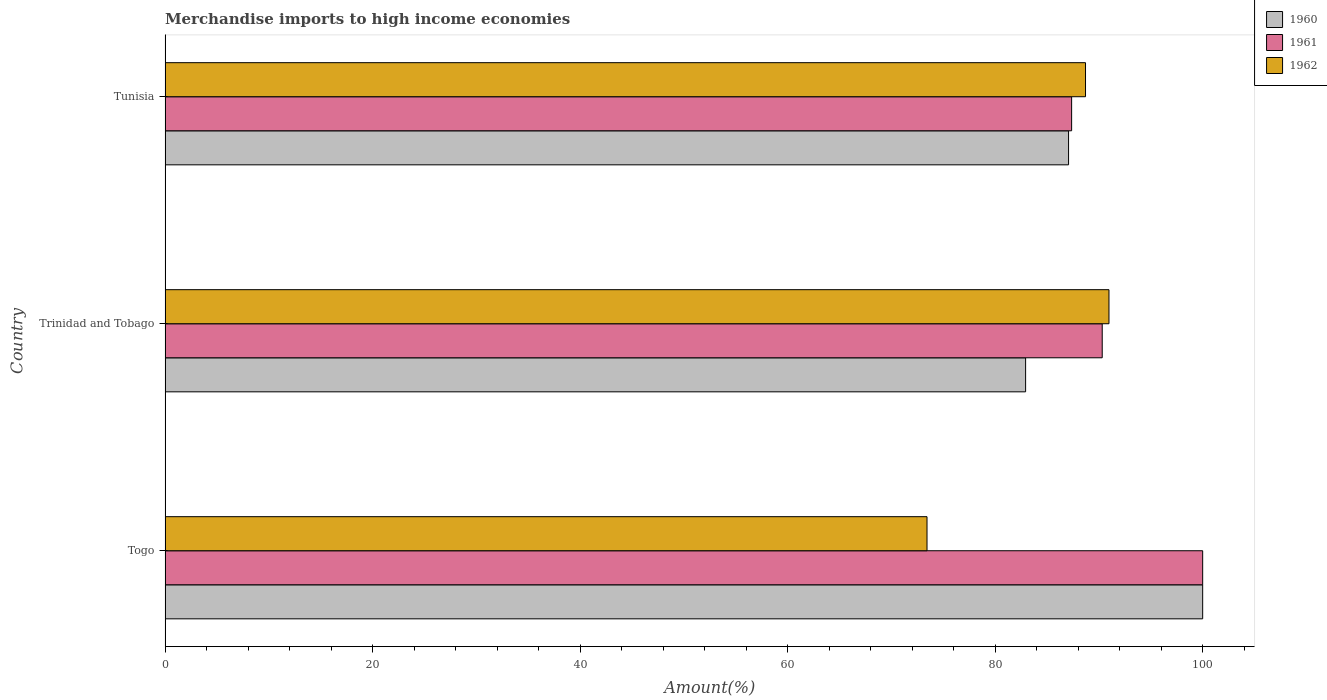Are the number of bars per tick equal to the number of legend labels?
Your answer should be very brief. Yes. How many bars are there on the 1st tick from the top?
Offer a very short reply. 3. What is the label of the 2nd group of bars from the top?
Ensure brevity in your answer.  Trinidad and Tobago. What is the percentage of amount earned from merchandise imports in 1960 in Tunisia?
Make the answer very short. 87.07. Across all countries, what is the maximum percentage of amount earned from merchandise imports in 1962?
Keep it short and to the point. 90.97. Across all countries, what is the minimum percentage of amount earned from merchandise imports in 1960?
Give a very brief answer. 82.93. In which country was the percentage of amount earned from merchandise imports in 1962 maximum?
Provide a succinct answer. Trinidad and Tobago. In which country was the percentage of amount earned from merchandise imports in 1960 minimum?
Provide a short and direct response. Trinidad and Tobago. What is the total percentage of amount earned from merchandise imports in 1961 in the graph?
Give a very brief answer. 277.69. What is the difference between the percentage of amount earned from merchandise imports in 1961 in Togo and that in Trinidad and Tobago?
Your response must be concise. 9.68. What is the difference between the percentage of amount earned from merchandise imports in 1962 in Tunisia and the percentage of amount earned from merchandise imports in 1961 in Trinidad and Tobago?
Provide a succinct answer. -1.61. What is the average percentage of amount earned from merchandise imports in 1960 per country?
Offer a very short reply. 90. What is the difference between the percentage of amount earned from merchandise imports in 1961 and percentage of amount earned from merchandise imports in 1960 in Trinidad and Tobago?
Provide a succinct answer. 7.38. What is the ratio of the percentage of amount earned from merchandise imports in 1960 in Togo to that in Trinidad and Tobago?
Give a very brief answer. 1.21. Is the percentage of amount earned from merchandise imports in 1961 in Togo less than that in Tunisia?
Your response must be concise. No. What is the difference between the highest and the second highest percentage of amount earned from merchandise imports in 1960?
Give a very brief answer. 12.93. What is the difference between the highest and the lowest percentage of amount earned from merchandise imports in 1962?
Provide a succinct answer. 17.54. What does the 2nd bar from the top in Trinidad and Tobago represents?
Your response must be concise. 1961. What is the difference between two consecutive major ticks on the X-axis?
Offer a very short reply. 20. Where does the legend appear in the graph?
Provide a succinct answer. Top right. How many legend labels are there?
Offer a very short reply. 3. What is the title of the graph?
Your answer should be very brief. Merchandise imports to high income economies. Does "1961" appear as one of the legend labels in the graph?
Offer a very short reply. Yes. What is the label or title of the X-axis?
Make the answer very short. Amount(%). What is the label or title of the Y-axis?
Provide a succinct answer. Country. What is the Amount(%) of 1962 in Togo?
Provide a short and direct response. 73.43. What is the Amount(%) of 1960 in Trinidad and Tobago?
Keep it short and to the point. 82.93. What is the Amount(%) in 1961 in Trinidad and Tobago?
Give a very brief answer. 90.32. What is the Amount(%) of 1962 in Trinidad and Tobago?
Offer a very short reply. 90.97. What is the Amount(%) of 1960 in Tunisia?
Provide a short and direct response. 87.07. What is the Amount(%) in 1961 in Tunisia?
Provide a short and direct response. 87.37. What is the Amount(%) in 1962 in Tunisia?
Keep it short and to the point. 88.71. Across all countries, what is the maximum Amount(%) of 1960?
Offer a terse response. 100. Across all countries, what is the maximum Amount(%) of 1961?
Give a very brief answer. 100. Across all countries, what is the maximum Amount(%) of 1962?
Give a very brief answer. 90.97. Across all countries, what is the minimum Amount(%) of 1960?
Make the answer very short. 82.93. Across all countries, what is the minimum Amount(%) in 1961?
Provide a succinct answer. 87.37. Across all countries, what is the minimum Amount(%) of 1962?
Provide a succinct answer. 73.43. What is the total Amount(%) in 1960 in the graph?
Offer a very short reply. 270.01. What is the total Amount(%) in 1961 in the graph?
Make the answer very short. 277.69. What is the total Amount(%) in 1962 in the graph?
Provide a succinct answer. 253.11. What is the difference between the Amount(%) in 1960 in Togo and that in Trinidad and Tobago?
Keep it short and to the point. 17.07. What is the difference between the Amount(%) of 1961 in Togo and that in Trinidad and Tobago?
Your answer should be compact. 9.68. What is the difference between the Amount(%) of 1962 in Togo and that in Trinidad and Tobago?
Keep it short and to the point. -17.54. What is the difference between the Amount(%) in 1960 in Togo and that in Tunisia?
Give a very brief answer. 12.93. What is the difference between the Amount(%) of 1961 in Togo and that in Tunisia?
Make the answer very short. 12.63. What is the difference between the Amount(%) of 1962 in Togo and that in Tunisia?
Your answer should be very brief. -15.28. What is the difference between the Amount(%) in 1960 in Trinidad and Tobago and that in Tunisia?
Provide a succinct answer. -4.14. What is the difference between the Amount(%) of 1961 in Trinidad and Tobago and that in Tunisia?
Ensure brevity in your answer.  2.95. What is the difference between the Amount(%) of 1962 in Trinidad and Tobago and that in Tunisia?
Your answer should be compact. 2.26. What is the difference between the Amount(%) in 1960 in Togo and the Amount(%) in 1961 in Trinidad and Tobago?
Make the answer very short. 9.68. What is the difference between the Amount(%) in 1960 in Togo and the Amount(%) in 1962 in Trinidad and Tobago?
Give a very brief answer. 9.03. What is the difference between the Amount(%) of 1961 in Togo and the Amount(%) of 1962 in Trinidad and Tobago?
Your response must be concise. 9.03. What is the difference between the Amount(%) in 1960 in Togo and the Amount(%) in 1961 in Tunisia?
Ensure brevity in your answer.  12.63. What is the difference between the Amount(%) in 1960 in Togo and the Amount(%) in 1962 in Tunisia?
Your answer should be compact. 11.29. What is the difference between the Amount(%) in 1961 in Togo and the Amount(%) in 1962 in Tunisia?
Keep it short and to the point. 11.29. What is the difference between the Amount(%) in 1960 in Trinidad and Tobago and the Amount(%) in 1961 in Tunisia?
Your answer should be very brief. -4.44. What is the difference between the Amount(%) in 1960 in Trinidad and Tobago and the Amount(%) in 1962 in Tunisia?
Your answer should be very brief. -5.77. What is the difference between the Amount(%) of 1961 in Trinidad and Tobago and the Amount(%) of 1962 in Tunisia?
Your answer should be compact. 1.61. What is the average Amount(%) of 1960 per country?
Give a very brief answer. 90. What is the average Amount(%) in 1961 per country?
Give a very brief answer. 92.56. What is the average Amount(%) of 1962 per country?
Provide a short and direct response. 84.37. What is the difference between the Amount(%) of 1960 and Amount(%) of 1961 in Togo?
Ensure brevity in your answer.  0. What is the difference between the Amount(%) of 1960 and Amount(%) of 1962 in Togo?
Provide a short and direct response. 26.57. What is the difference between the Amount(%) in 1961 and Amount(%) in 1962 in Togo?
Keep it short and to the point. 26.57. What is the difference between the Amount(%) of 1960 and Amount(%) of 1961 in Trinidad and Tobago?
Your answer should be very brief. -7.38. What is the difference between the Amount(%) of 1960 and Amount(%) of 1962 in Trinidad and Tobago?
Your answer should be compact. -8.03. What is the difference between the Amount(%) of 1961 and Amount(%) of 1962 in Trinidad and Tobago?
Give a very brief answer. -0.65. What is the difference between the Amount(%) in 1960 and Amount(%) in 1961 in Tunisia?
Offer a terse response. -0.3. What is the difference between the Amount(%) in 1960 and Amount(%) in 1962 in Tunisia?
Your answer should be very brief. -1.63. What is the difference between the Amount(%) in 1961 and Amount(%) in 1962 in Tunisia?
Offer a very short reply. -1.34. What is the ratio of the Amount(%) of 1960 in Togo to that in Trinidad and Tobago?
Provide a short and direct response. 1.21. What is the ratio of the Amount(%) in 1961 in Togo to that in Trinidad and Tobago?
Offer a terse response. 1.11. What is the ratio of the Amount(%) in 1962 in Togo to that in Trinidad and Tobago?
Provide a short and direct response. 0.81. What is the ratio of the Amount(%) of 1960 in Togo to that in Tunisia?
Ensure brevity in your answer.  1.15. What is the ratio of the Amount(%) in 1961 in Togo to that in Tunisia?
Ensure brevity in your answer.  1.14. What is the ratio of the Amount(%) of 1962 in Togo to that in Tunisia?
Provide a short and direct response. 0.83. What is the ratio of the Amount(%) in 1961 in Trinidad and Tobago to that in Tunisia?
Offer a terse response. 1.03. What is the ratio of the Amount(%) of 1962 in Trinidad and Tobago to that in Tunisia?
Your answer should be compact. 1.03. What is the difference between the highest and the second highest Amount(%) of 1960?
Your response must be concise. 12.93. What is the difference between the highest and the second highest Amount(%) of 1961?
Your answer should be very brief. 9.68. What is the difference between the highest and the second highest Amount(%) of 1962?
Your answer should be compact. 2.26. What is the difference between the highest and the lowest Amount(%) in 1960?
Provide a short and direct response. 17.07. What is the difference between the highest and the lowest Amount(%) of 1961?
Provide a short and direct response. 12.63. What is the difference between the highest and the lowest Amount(%) in 1962?
Offer a very short reply. 17.54. 